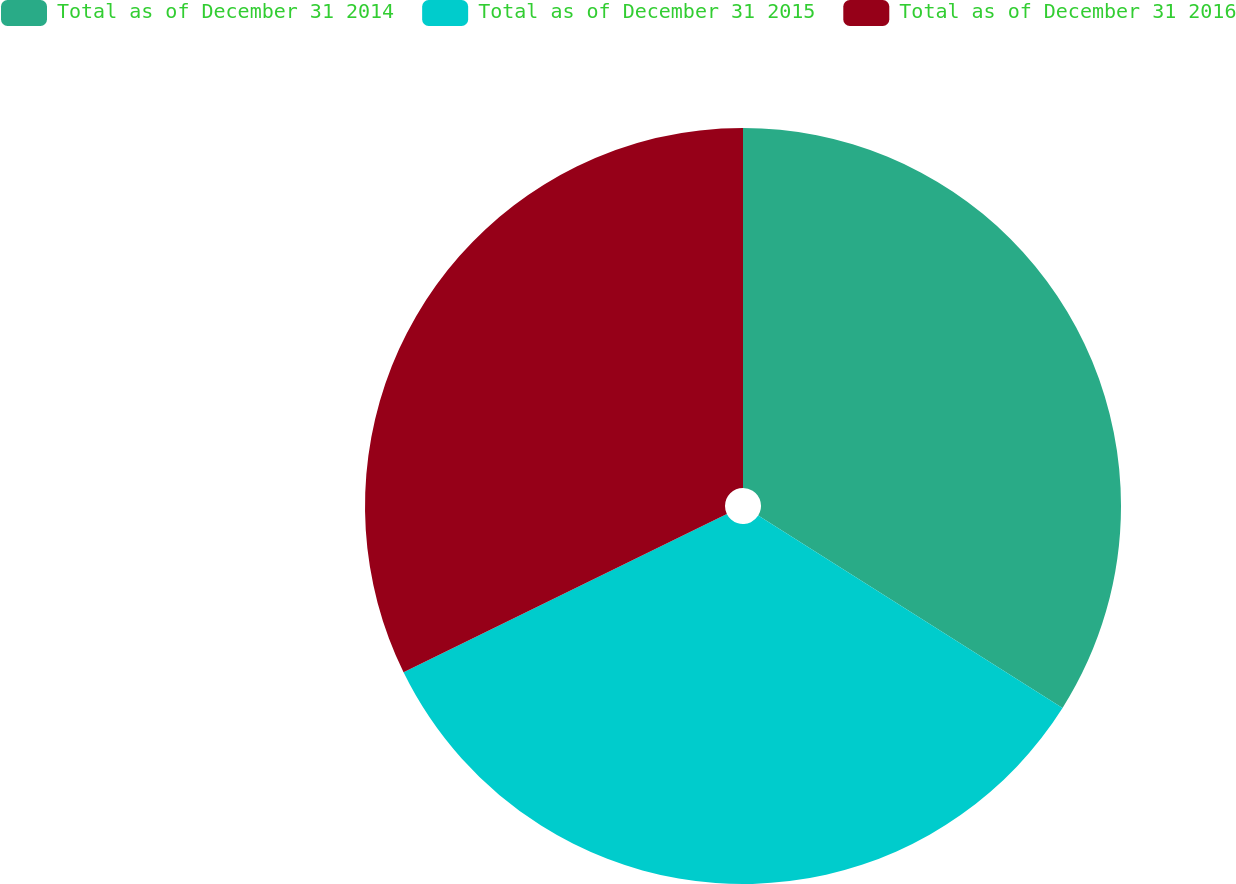Convert chart. <chart><loc_0><loc_0><loc_500><loc_500><pie_chart><fcel>Total as of December 31 2014<fcel>Total as of December 31 2015<fcel>Total as of December 31 2016<nl><fcel>33.97%<fcel>33.78%<fcel>32.25%<nl></chart> 